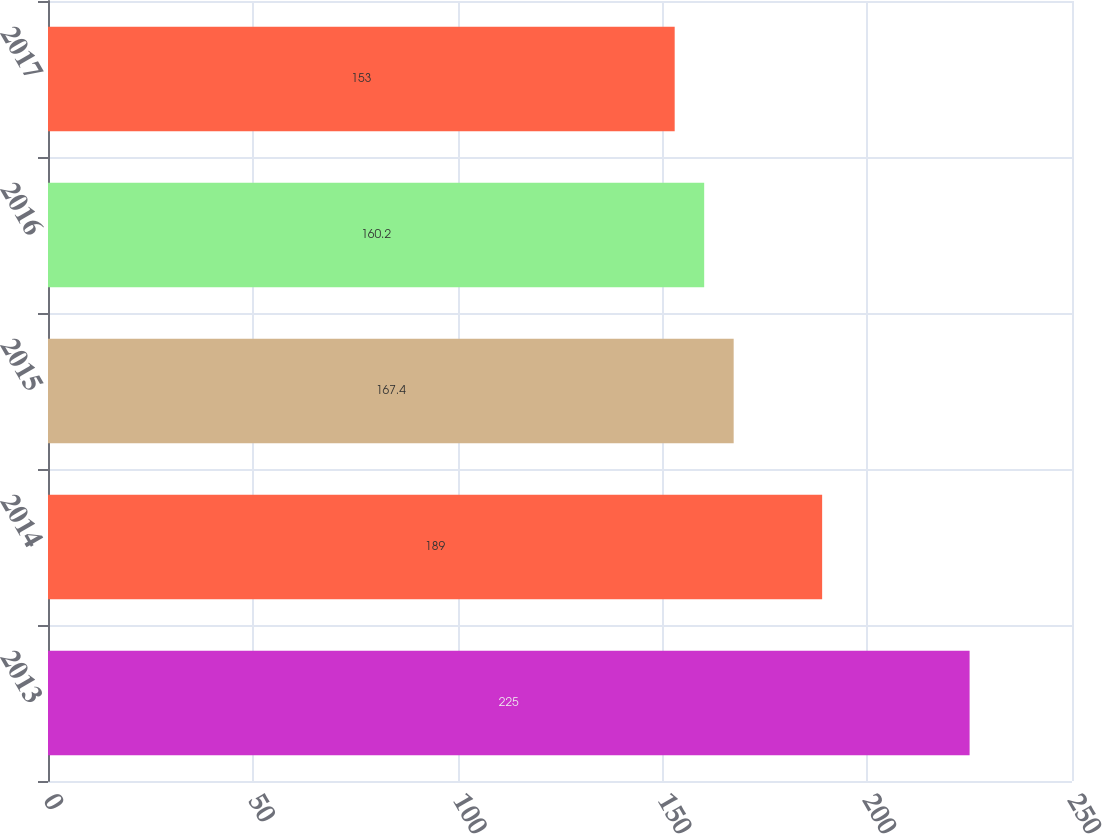Convert chart. <chart><loc_0><loc_0><loc_500><loc_500><bar_chart><fcel>2013<fcel>2014<fcel>2015<fcel>2016<fcel>2017<nl><fcel>225<fcel>189<fcel>167.4<fcel>160.2<fcel>153<nl></chart> 